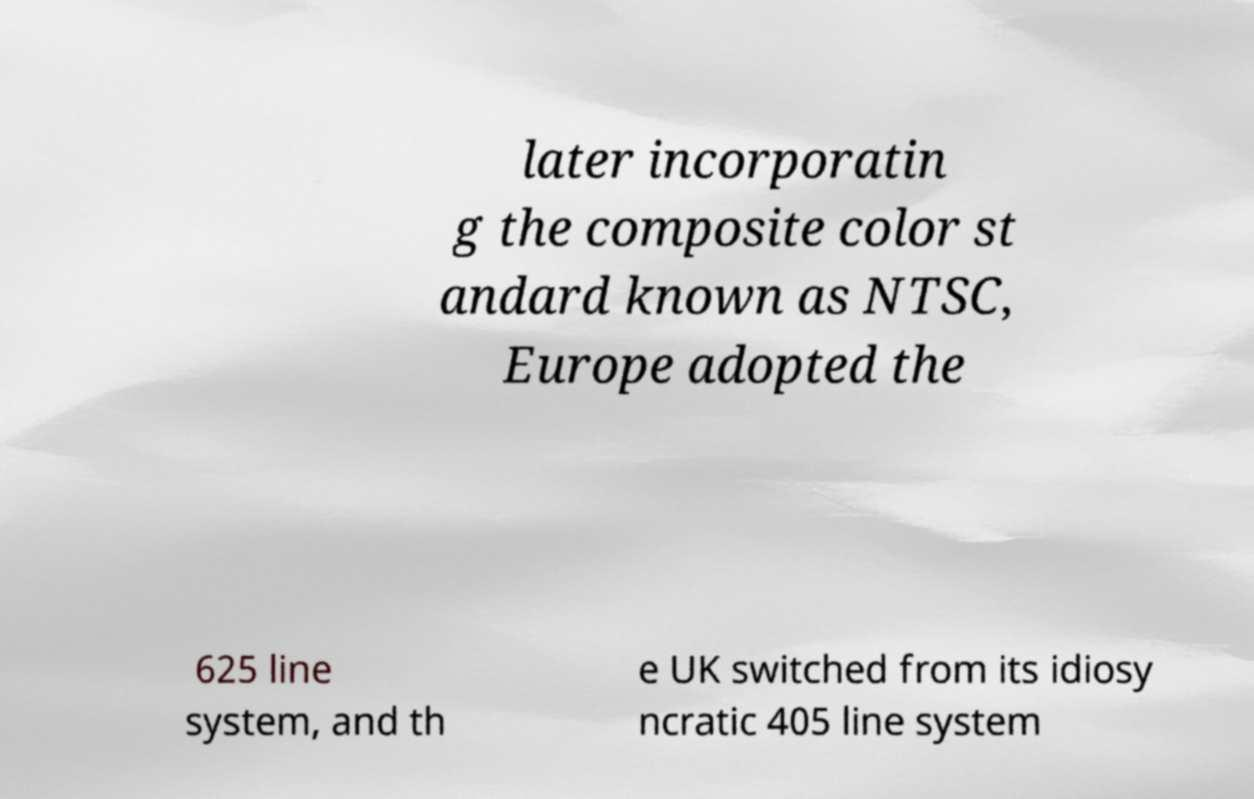Can you read and provide the text displayed in the image?This photo seems to have some interesting text. Can you extract and type it out for me? later incorporatin g the composite color st andard known as NTSC, Europe adopted the 625 line system, and th e UK switched from its idiosy ncratic 405 line system 